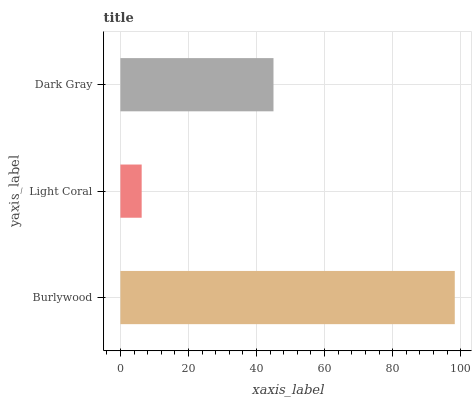Is Light Coral the minimum?
Answer yes or no. Yes. Is Burlywood the maximum?
Answer yes or no. Yes. Is Dark Gray the minimum?
Answer yes or no. No. Is Dark Gray the maximum?
Answer yes or no. No. Is Dark Gray greater than Light Coral?
Answer yes or no. Yes. Is Light Coral less than Dark Gray?
Answer yes or no. Yes. Is Light Coral greater than Dark Gray?
Answer yes or no. No. Is Dark Gray less than Light Coral?
Answer yes or no. No. Is Dark Gray the high median?
Answer yes or no. Yes. Is Dark Gray the low median?
Answer yes or no. Yes. Is Light Coral the high median?
Answer yes or no. No. Is Light Coral the low median?
Answer yes or no. No. 